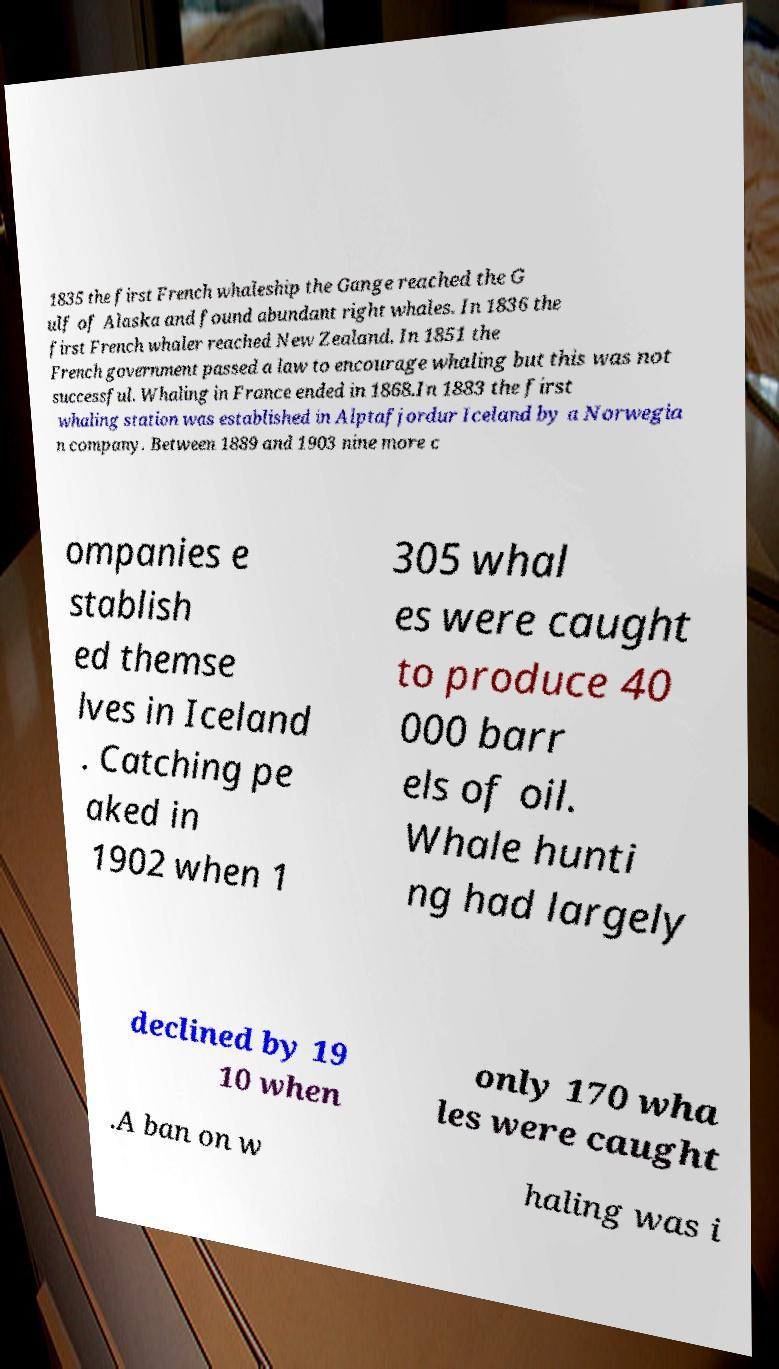Can you accurately transcribe the text from the provided image for me? 1835 the first French whaleship the Gange reached the G ulf of Alaska and found abundant right whales. In 1836 the first French whaler reached New Zealand. In 1851 the French government passed a law to encourage whaling but this was not successful. Whaling in France ended in 1868.In 1883 the first whaling station was established in Alptafjordur Iceland by a Norwegia n company. Between 1889 and 1903 nine more c ompanies e stablish ed themse lves in Iceland . Catching pe aked in 1902 when 1 305 whal es were caught to produce 40 000 barr els of oil. Whale hunti ng had largely declined by 19 10 when only 170 wha les were caught .A ban on w haling was i 